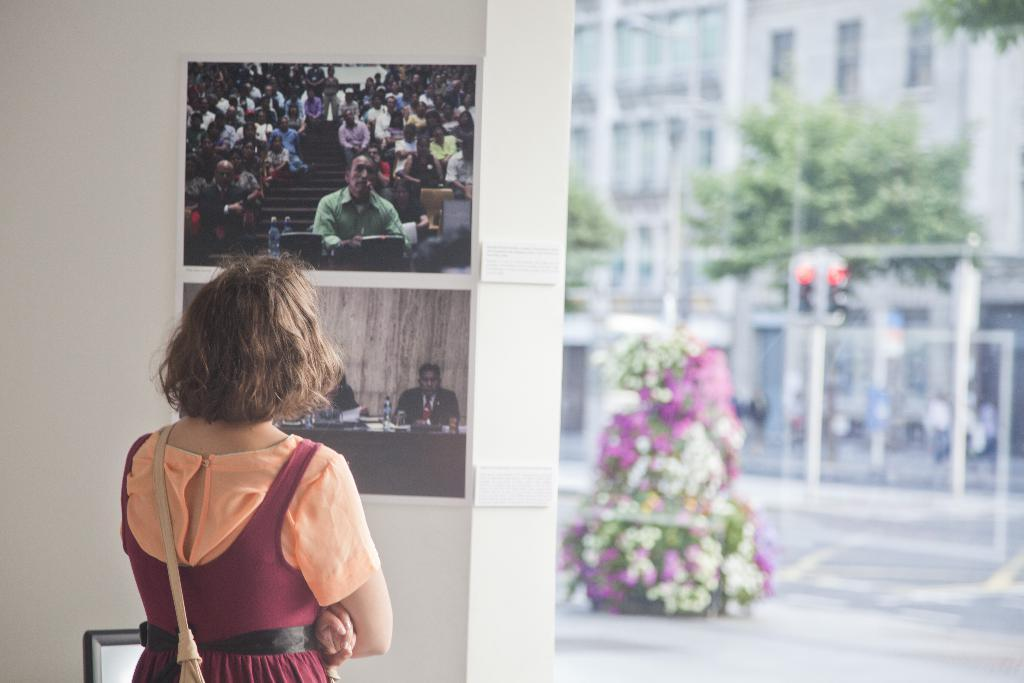Who is the main subject in the image? There is a lady in the image. What is the lady wearing? The lady is wearing a bag. What can be seen in the background of the image? There are posters on the wall and a frame visible in the background. What is the lady's sister doing in the image? There is no mention of a sister in the image, so we cannot determine what the sister might be doing. 